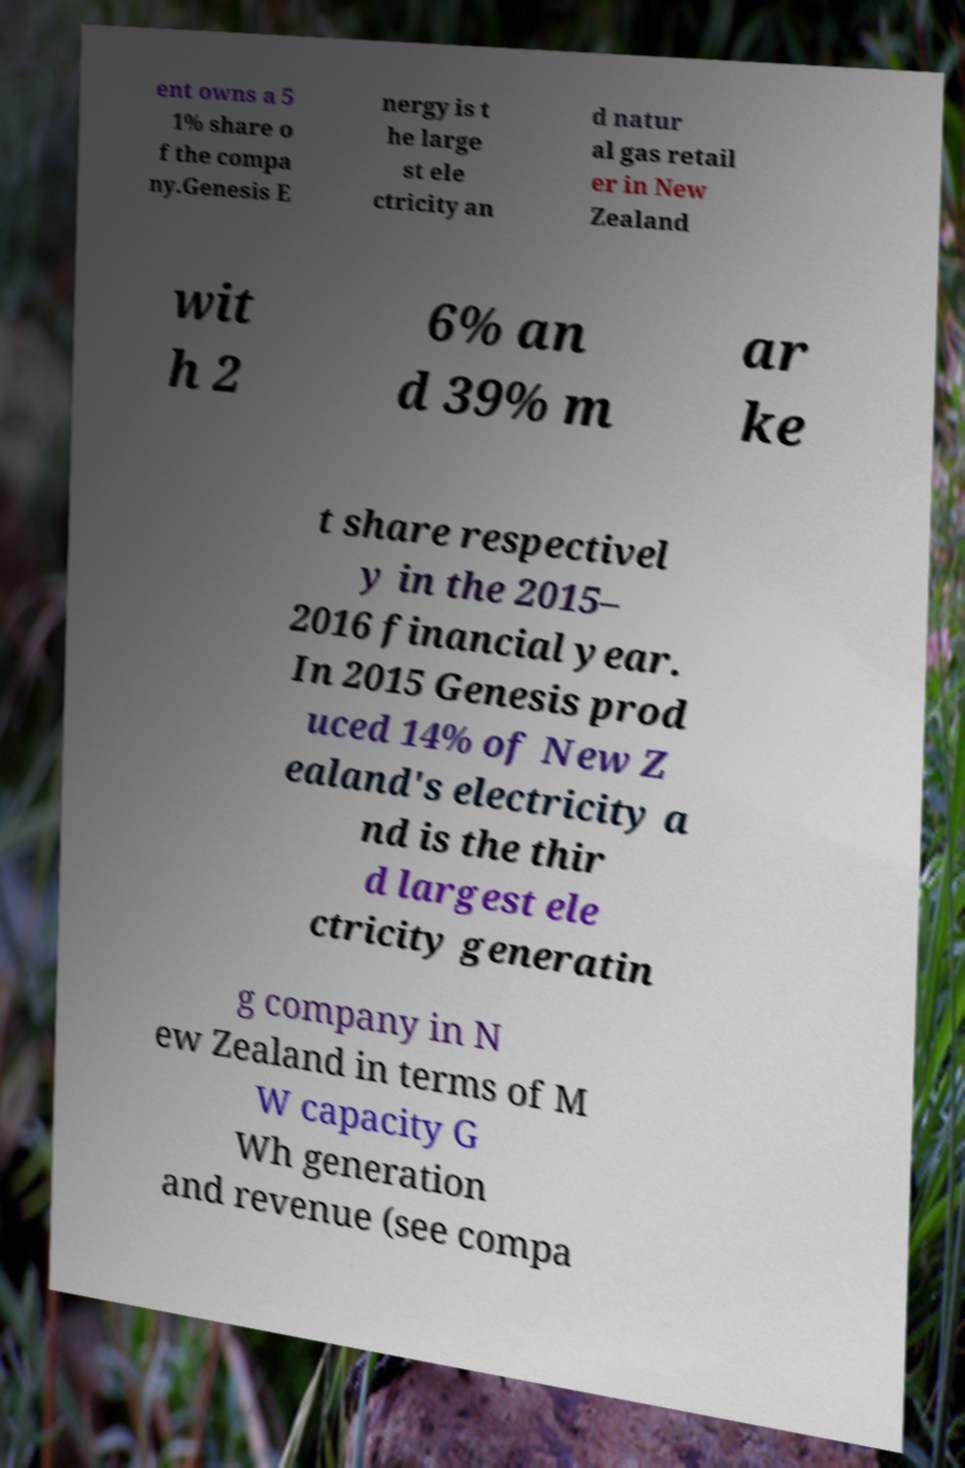Could you extract and type out the text from this image? ent owns a 5 1% share o f the compa ny.Genesis E nergy is t he large st ele ctricity an d natur al gas retail er in New Zealand wit h 2 6% an d 39% m ar ke t share respectivel y in the 2015– 2016 financial year. In 2015 Genesis prod uced 14% of New Z ealand's electricity a nd is the thir d largest ele ctricity generatin g company in N ew Zealand in terms of M W capacity G Wh generation and revenue (see compa 